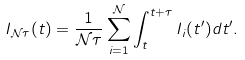<formula> <loc_0><loc_0><loc_500><loc_500>I _ { \mathcal { N } \tau } ( t ) = \frac { 1 } { { \mathcal { N } } \tau } \sum _ { i = 1 } ^ { { \mathcal { N } } } \int _ { t } ^ { t + \tau } I _ { i } ( t ^ { \prime } ) d t ^ { \prime } .</formula> 